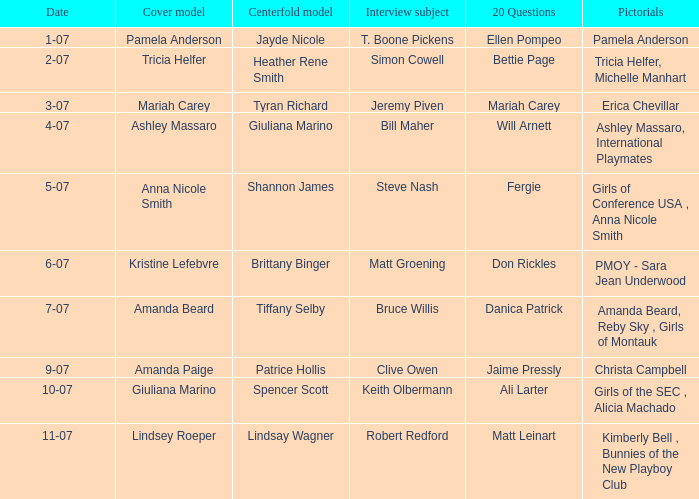Who served as the cover model when the issue's visuals were pmoy - sara jean underwood? Kristine Lefebvre. Give me the full table as a dictionary. {'header': ['Date', 'Cover model', 'Centerfold model', 'Interview subject', '20 Questions', 'Pictorials'], 'rows': [['1-07', 'Pamela Anderson', 'Jayde Nicole', 'T. Boone Pickens', 'Ellen Pompeo', 'Pamela Anderson'], ['2-07', 'Tricia Helfer', 'Heather Rene Smith', 'Simon Cowell', 'Bettie Page', 'Tricia Helfer, Michelle Manhart'], ['3-07', 'Mariah Carey', 'Tyran Richard', 'Jeremy Piven', 'Mariah Carey', 'Erica Chevillar'], ['4-07', 'Ashley Massaro', 'Giuliana Marino', 'Bill Maher', 'Will Arnett', 'Ashley Massaro, International Playmates'], ['5-07', 'Anna Nicole Smith', 'Shannon James', 'Steve Nash', 'Fergie', 'Girls of Conference USA , Anna Nicole Smith'], ['6-07', 'Kristine Lefebvre', 'Brittany Binger', 'Matt Groening', 'Don Rickles', 'PMOY - Sara Jean Underwood'], ['7-07', 'Amanda Beard', 'Tiffany Selby', 'Bruce Willis', 'Danica Patrick', 'Amanda Beard, Reby Sky , Girls of Montauk'], ['9-07', 'Amanda Paige', 'Patrice Hollis', 'Clive Owen', 'Jaime Pressly', 'Christa Campbell'], ['10-07', 'Giuliana Marino', 'Spencer Scott', 'Keith Olbermann', 'Ali Larter', 'Girls of the SEC , Alicia Machado'], ['11-07', 'Lindsey Roeper', 'Lindsay Wagner', 'Robert Redford', 'Matt Leinart', 'Kimberly Bell , Bunnies of the New Playboy Club']]} 